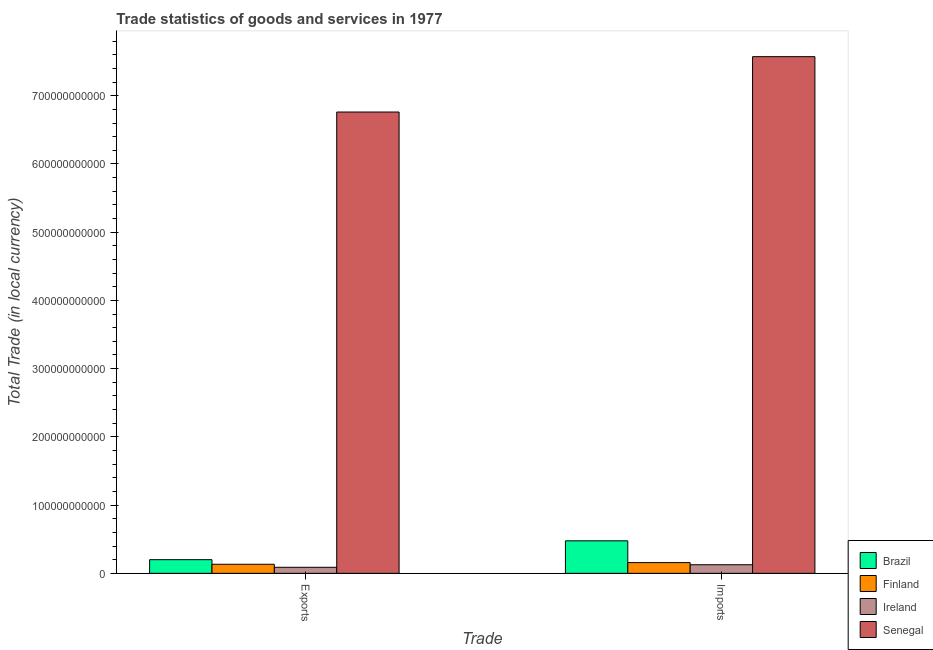How many groups of bars are there?
Ensure brevity in your answer.  2. Are the number of bars per tick equal to the number of legend labels?
Give a very brief answer. Yes. How many bars are there on the 2nd tick from the left?
Offer a very short reply. 4. How many bars are there on the 1st tick from the right?
Offer a very short reply. 4. What is the label of the 2nd group of bars from the left?
Make the answer very short. Imports. What is the export of goods and services in Finland?
Keep it short and to the point. 1.33e+1. Across all countries, what is the maximum imports of goods and services?
Your answer should be very brief. 7.57e+11. Across all countries, what is the minimum export of goods and services?
Offer a terse response. 8.85e+09. In which country was the imports of goods and services maximum?
Offer a terse response. Senegal. In which country was the imports of goods and services minimum?
Your answer should be very brief. Ireland. What is the total imports of goods and services in the graph?
Give a very brief answer. 8.33e+11. What is the difference between the export of goods and services in Brazil and that in Senegal?
Make the answer very short. -6.56e+11. What is the difference between the imports of goods and services in Finland and the export of goods and services in Ireland?
Offer a terse response. 6.87e+09. What is the average imports of goods and services per country?
Ensure brevity in your answer.  2.08e+11. What is the difference between the imports of goods and services and export of goods and services in Brazil?
Offer a terse response. 2.76e+1. What is the ratio of the export of goods and services in Brazil to that in Senegal?
Provide a short and direct response. 0.03. What does the 2nd bar from the right in Imports represents?
Offer a terse response. Ireland. How many bars are there?
Your answer should be compact. 8. How many countries are there in the graph?
Provide a short and direct response. 4. What is the difference between two consecutive major ticks on the Y-axis?
Offer a very short reply. 1.00e+11. Are the values on the major ticks of Y-axis written in scientific E-notation?
Make the answer very short. No. Does the graph contain any zero values?
Provide a succinct answer. No. Does the graph contain grids?
Provide a short and direct response. No. How are the legend labels stacked?
Give a very brief answer. Vertical. What is the title of the graph?
Give a very brief answer. Trade statistics of goods and services in 1977. Does "Bahrain" appear as one of the legend labels in the graph?
Make the answer very short. No. What is the label or title of the X-axis?
Offer a terse response. Trade. What is the label or title of the Y-axis?
Your answer should be very brief. Total Trade (in local currency). What is the Total Trade (in local currency) in Brazil in Exports?
Make the answer very short. 2.00e+1. What is the Total Trade (in local currency) in Finland in Exports?
Keep it short and to the point. 1.33e+1. What is the Total Trade (in local currency) of Ireland in Exports?
Provide a short and direct response. 8.85e+09. What is the Total Trade (in local currency) of Senegal in Exports?
Your answer should be compact. 6.76e+11. What is the Total Trade (in local currency) of Brazil in Imports?
Your response must be concise. 4.77e+1. What is the Total Trade (in local currency) of Finland in Imports?
Keep it short and to the point. 1.57e+1. What is the Total Trade (in local currency) of Ireland in Imports?
Offer a terse response. 1.26e+1. What is the Total Trade (in local currency) of Senegal in Imports?
Offer a terse response. 7.57e+11. Across all Trade, what is the maximum Total Trade (in local currency) in Brazil?
Offer a terse response. 4.77e+1. Across all Trade, what is the maximum Total Trade (in local currency) of Finland?
Keep it short and to the point. 1.57e+1. Across all Trade, what is the maximum Total Trade (in local currency) in Ireland?
Keep it short and to the point. 1.26e+1. Across all Trade, what is the maximum Total Trade (in local currency) in Senegal?
Provide a succinct answer. 7.57e+11. Across all Trade, what is the minimum Total Trade (in local currency) in Brazil?
Keep it short and to the point. 2.00e+1. Across all Trade, what is the minimum Total Trade (in local currency) in Finland?
Ensure brevity in your answer.  1.33e+1. Across all Trade, what is the minimum Total Trade (in local currency) of Ireland?
Ensure brevity in your answer.  8.85e+09. Across all Trade, what is the minimum Total Trade (in local currency) of Senegal?
Provide a succinct answer. 6.76e+11. What is the total Total Trade (in local currency) of Brazil in the graph?
Keep it short and to the point. 6.77e+1. What is the total Total Trade (in local currency) in Finland in the graph?
Ensure brevity in your answer.  2.90e+1. What is the total Total Trade (in local currency) in Ireland in the graph?
Your answer should be very brief. 2.15e+1. What is the total Total Trade (in local currency) of Senegal in the graph?
Your answer should be compact. 1.43e+12. What is the difference between the Total Trade (in local currency) in Brazil in Exports and that in Imports?
Your answer should be compact. -2.76e+1. What is the difference between the Total Trade (in local currency) of Finland in Exports and that in Imports?
Your response must be concise. -2.45e+09. What is the difference between the Total Trade (in local currency) of Ireland in Exports and that in Imports?
Your response must be concise. -3.75e+09. What is the difference between the Total Trade (in local currency) of Senegal in Exports and that in Imports?
Offer a terse response. -8.11e+1. What is the difference between the Total Trade (in local currency) in Brazil in Exports and the Total Trade (in local currency) in Finland in Imports?
Provide a succinct answer. 4.29e+09. What is the difference between the Total Trade (in local currency) of Brazil in Exports and the Total Trade (in local currency) of Ireland in Imports?
Offer a terse response. 7.42e+09. What is the difference between the Total Trade (in local currency) in Brazil in Exports and the Total Trade (in local currency) in Senegal in Imports?
Offer a terse response. -7.37e+11. What is the difference between the Total Trade (in local currency) of Finland in Exports and the Total Trade (in local currency) of Ireland in Imports?
Offer a terse response. 6.81e+08. What is the difference between the Total Trade (in local currency) in Finland in Exports and the Total Trade (in local currency) in Senegal in Imports?
Provide a short and direct response. -7.44e+11. What is the difference between the Total Trade (in local currency) of Ireland in Exports and the Total Trade (in local currency) of Senegal in Imports?
Keep it short and to the point. -7.48e+11. What is the average Total Trade (in local currency) of Brazil per Trade?
Offer a terse response. 3.38e+1. What is the average Total Trade (in local currency) of Finland per Trade?
Provide a succinct answer. 1.45e+1. What is the average Total Trade (in local currency) of Ireland per Trade?
Your answer should be very brief. 1.07e+1. What is the average Total Trade (in local currency) in Senegal per Trade?
Offer a terse response. 7.17e+11. What is the difference between the Total Trade (in local currency) of Brazil and Total Trade (in local currency) of Finland in Exports?
Ensure brevity in your answer.  6.74e+09. What is the difference between the Total Trade (in local currency) in Brazil and Total Trade (in local currency) in Ireland in Exports?
Provide a succinct answer. 1.12e+1. What is the difference between the Total Trade (in local currency) of Brazil and Total Trade (in local currency) of Senegal in Exports?
Offer a terse response. -6.56e+11. What is the difference between the Total Trade (in local currency) in Finland and Total Trade (in local currency) in Ireland in Exports?
Make the answer very short. 4.43e+09. What is the difference between the Total Trade (in local currency) in Finland and Total Trade (in local currency) in Senegal in Exports?
Offer a terse response. -6.63e+11. What is the difference between the Total Trade (in local currency) in Ireland and Total Trade (in local currency) in Senegal in Exports?
Your answer should be compact. -6.67e+11. What is the difference between the Total Trade (in local currency) in Brazil and Total Trade (in local currency) in Finland in Imports?
Your response must be concise. 3.19e+1. What is the difference between the Total Trade (in local currency) of Brazil and Total Trade (in local currency) of Ireland in Imports?
Your response must be concise. 3.51e+1. What is the difference between the Total Trade (in local currency) of Brazil and Total Trade (in local currency) of Senegal in Imports?
Give a very brief answer. -7.10e+11. What is the difference between the Total Trade (in local currency) in Finland and Total Trade (in local currency) in Ireland in Imports?
Your answer should be compact. 3.13e+09. What is the difference between the Total Trade (in local currency) of Finland and Total Trade (in local currency) of Senegal in Imports?
Provide a short and direct response. -7.42e+11. What is the difference between the Total Trade (in local currency) of Ireland and Total Trade (in local currency) of Senegal in Imports?
Offer a very short reply. -7.45e+11. What is the ratio of the Total Trade (in local currency) in Brazil in Exports to that in Imports?
Your response must be concise. 0.42. What is the ratio of the Total Trade (in local currency) in Finland in Exports to that in Imports?
Offer a terse response. 0.84. What is the ratio of the Total Trade (in local currency) in Ireland in Exports to that in Imports?
Provide a short and direct response. 0.7. What is the ratio of the Total Trade (in local currency) in Senegal in Exports to that in Imports?
Give a very brief answer. 0.89. What is the difference between the highest and the second highest Total Trade (in local currency) in Brazil?
Your answer should be very brief. 2.76e+1. What is the difference between the highest and the second highest Total Trade (in local currency) of Finland?
Keep it short and to the point. 2.45e+09. What is the difference between the highest and the second highest Total Trade (in local currency) in Ireland?
Keep it short and to the point. 3.75e+09. What is the difference between the highest and the second highest Total Trade (in local currency) of Senegal?
Your response must be concise. 8.11e+1. What is the difference between the highest and the lowest Total Trade (in local currency) in Brazil?
Your response must be concise. 2.76e+1. What is the difference between the highest and the lowest Total Trade (in local currency) of Finland?
Provide a short and direct response. 2.45e+09. What is the difference between the highest and the lowest Total Trade (in local currency) in Ireland?
Ensure brevity in your answer.  3.75e+09. What is the difference between the highest and the lowest Total Trade (in local currency) of Senegal?
Offer a very short reply. 8.11e+1. 